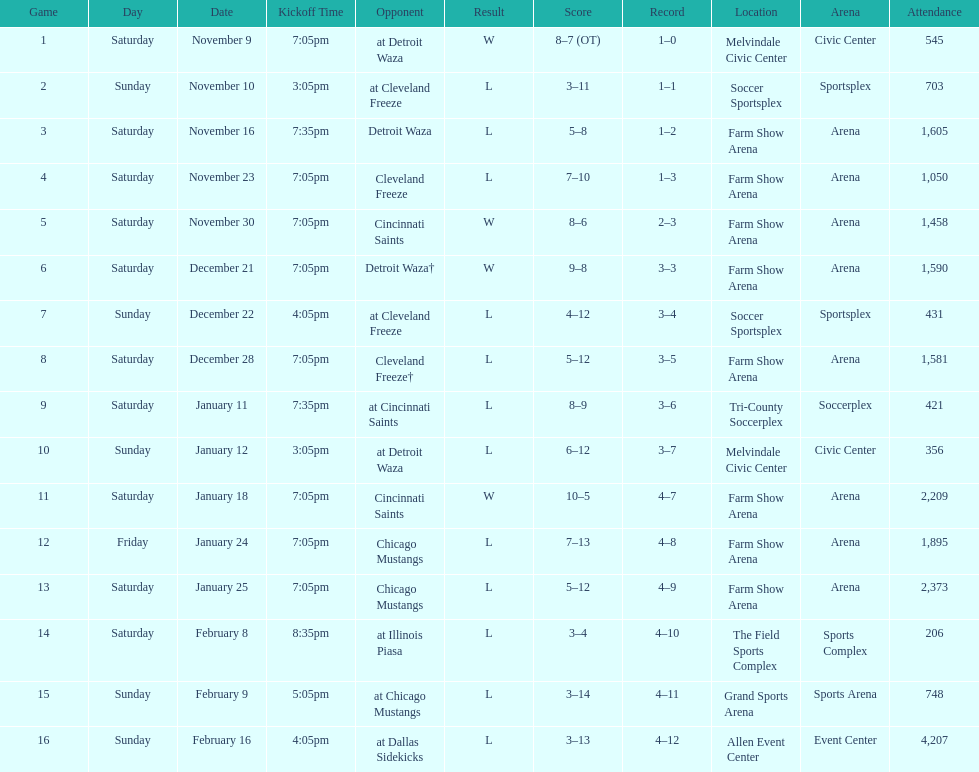How long was the teams longest losing streak? 5 games. 